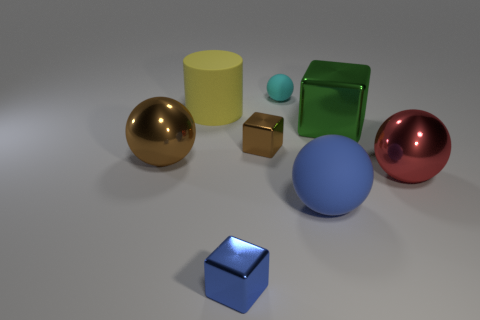What number of things are either metal spheres on the right side of the tiny cyan rubber thing or small purple shiny cylinders?
Your answer should be very brief. 1. Are there the same number of big yellow cylinders that are behind the large yellow cylinder and large shiny cubes in front of the red metallic object?
Offer a very short reply. Yes. What number of other objects are the same shape as the big yellow matte thing?
Provide a short and direct response. 0. There is a brown metallic sphere that is behind the blue metallic block; does it have the same size as the rubber thing in front of the red metallic sphere?
Offer a very short reply. Yes. How many cylinders are either matte objects or small green rubber objects?
Your response must be concise. 1. What number of rubber objects are either tiny blue objects or big blocks?
Keep it short and to the point. 0. What size is the brown metal thing that is the same shape as the green metal object?
Provide a short and direct response. Small. Is there anything else that is the same size as the cyan matte ball?
Your answer should be compact. Yes. Does the red ball have the same size as the shiny sphere left of the blue metallic object?
Keep it short and to the point. Yes. There is a large matte object to the left of the large blue matte ball; what is its shape?
Offer a very short reply. Cylinder. 